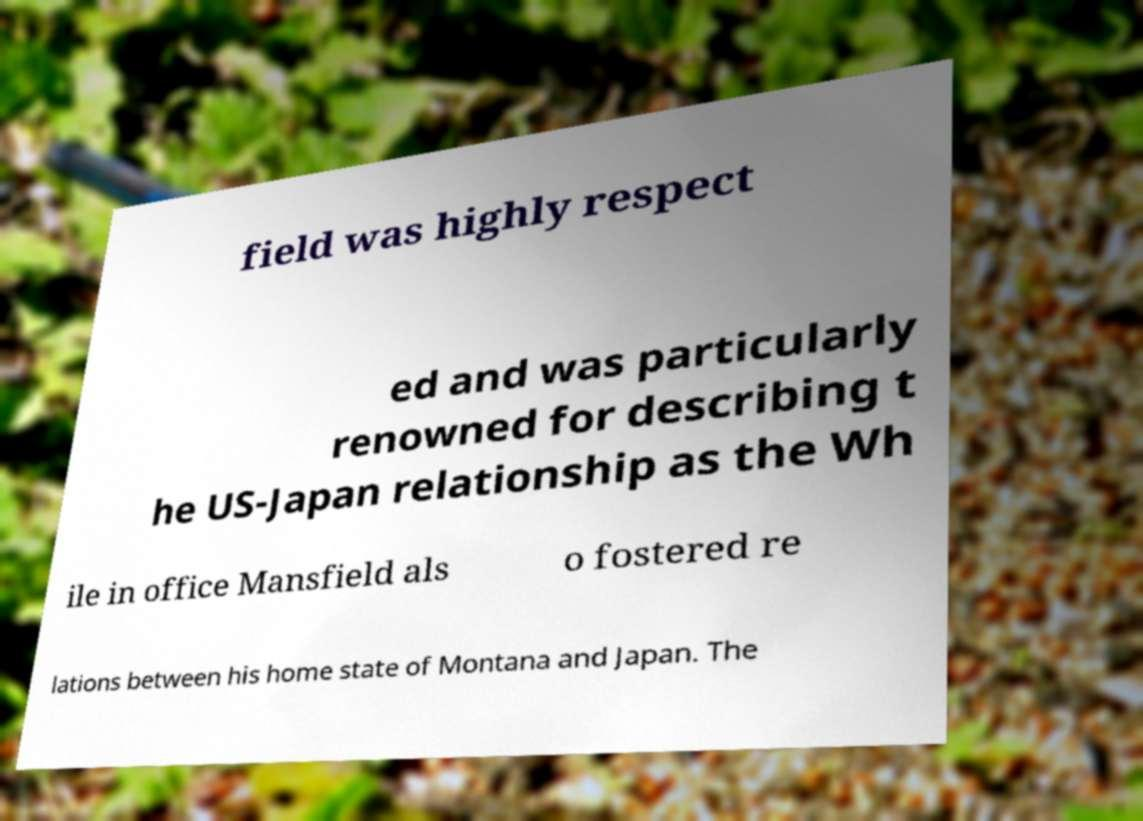Could you extract and type out the text from this image? field was highly respect ed and was particularly renowned for describing t he US-Japan relationship as the Wh ile in office Mansfield als o fostered re lations between his home state of Montana and Japan. The 